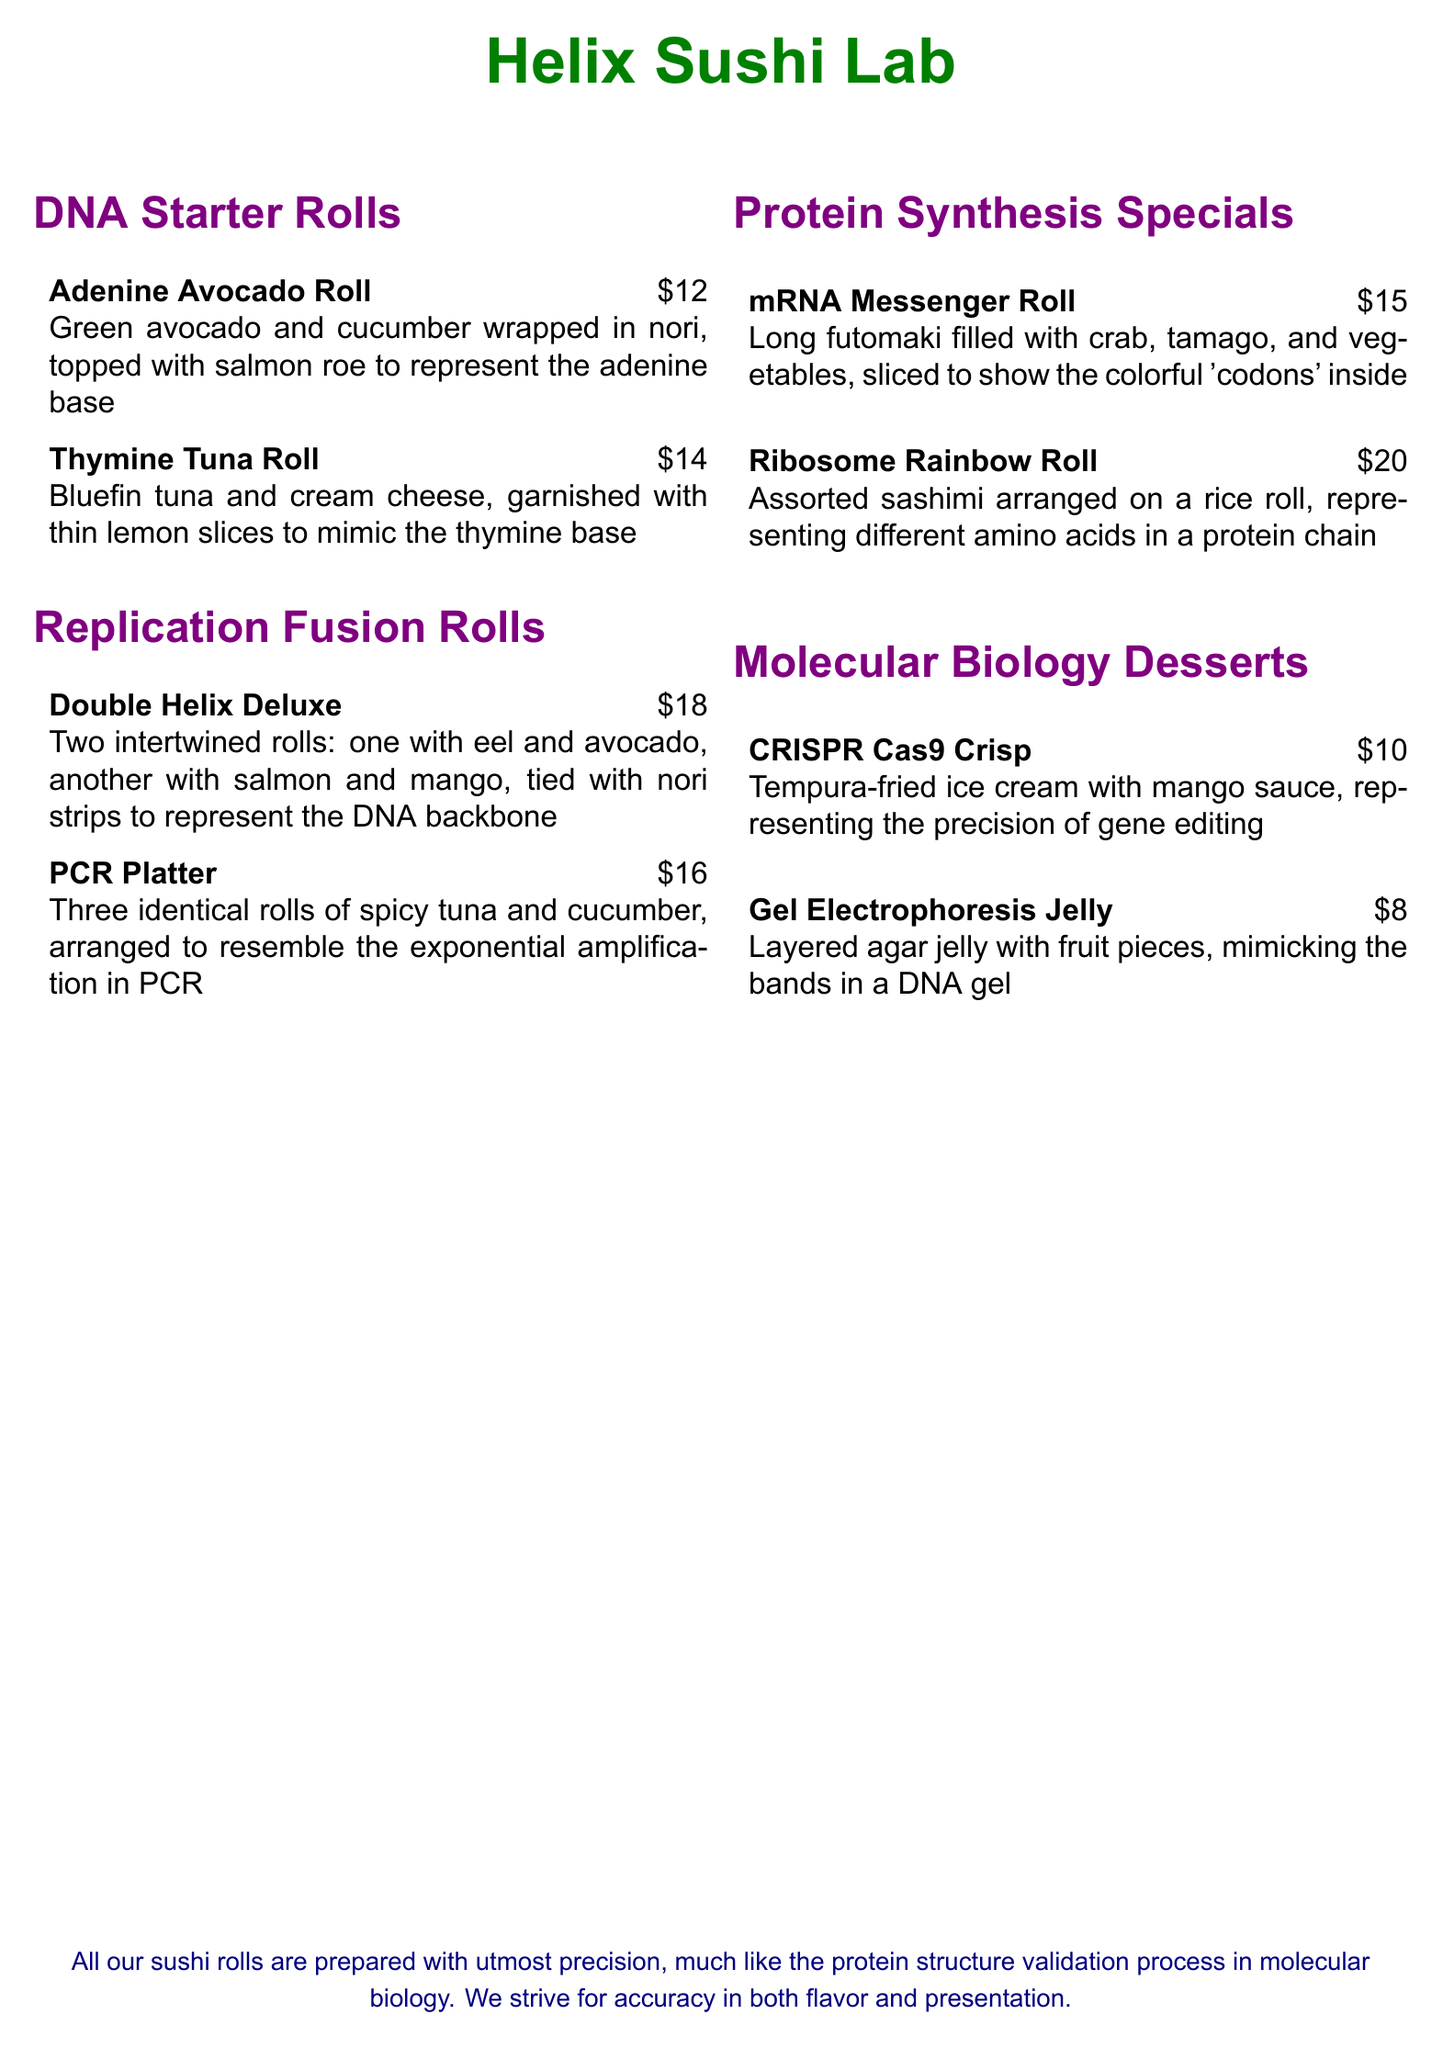what is the price of the Adenine Avocado Roll? The price is mentioned next to the item on the menu.
Answer: $12 how many items are listed under Protein Synthesis Specials? The number of items under this section is countable from the menu.
Answer: 2 what is the main filling of the Thymine Tuna Roll? The filling is described in the menu description of this roll.
Answer: Bluefin tuna and cream cheese which dessert represents the precision of gene editing? The menu explicitly states which dessert represents this concept.
Answer: CRISPR Cas9 Crisp what is the unique feature of the Double Helix Deluxe? The description indicates that it features intertwined rolls representing a structure.
Answer: Two intertwined rolls how many identical rolls are present in the PCR Platter? The number of rolls is indicated in the description of this platter.
Answer: Three what colors are used in the menu titles? The menu describes the colors used in the titles throughout the document.
Answer: Purple what is the price of the Ribosome Rainbow Roll? The price is listed directly next to the item on the menu.
Answer: $20 